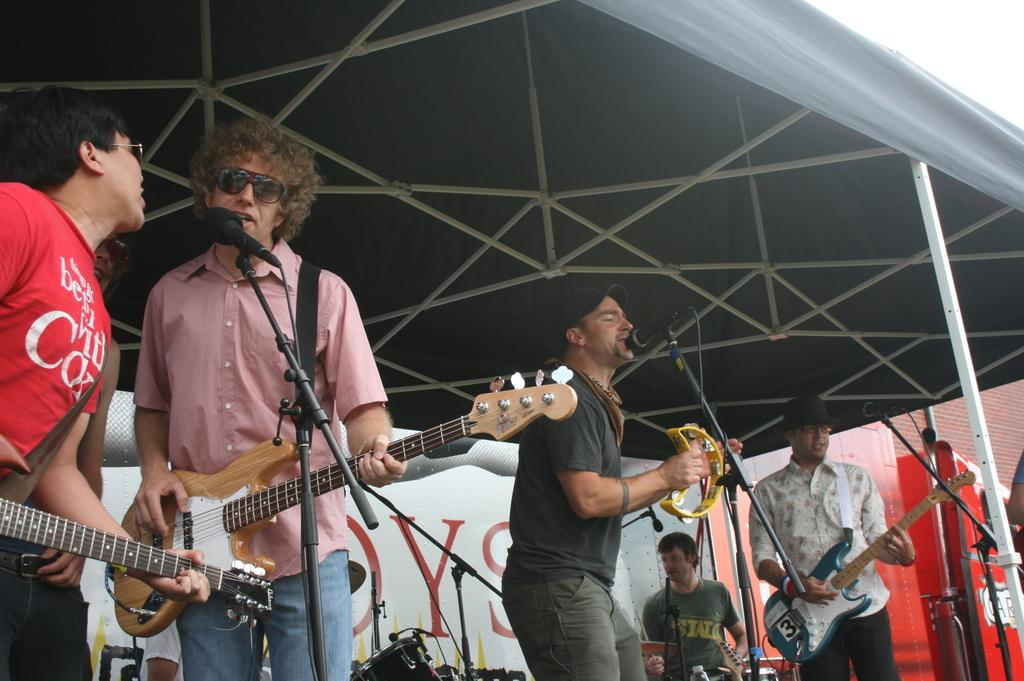How many people are in the image? There is a group of people in the image. What are the people in the image doing? The people are playing musical instruments. What type of paste is being used by the musicians in the image? There is no paste present in the image; the people are playing musical instruments. 